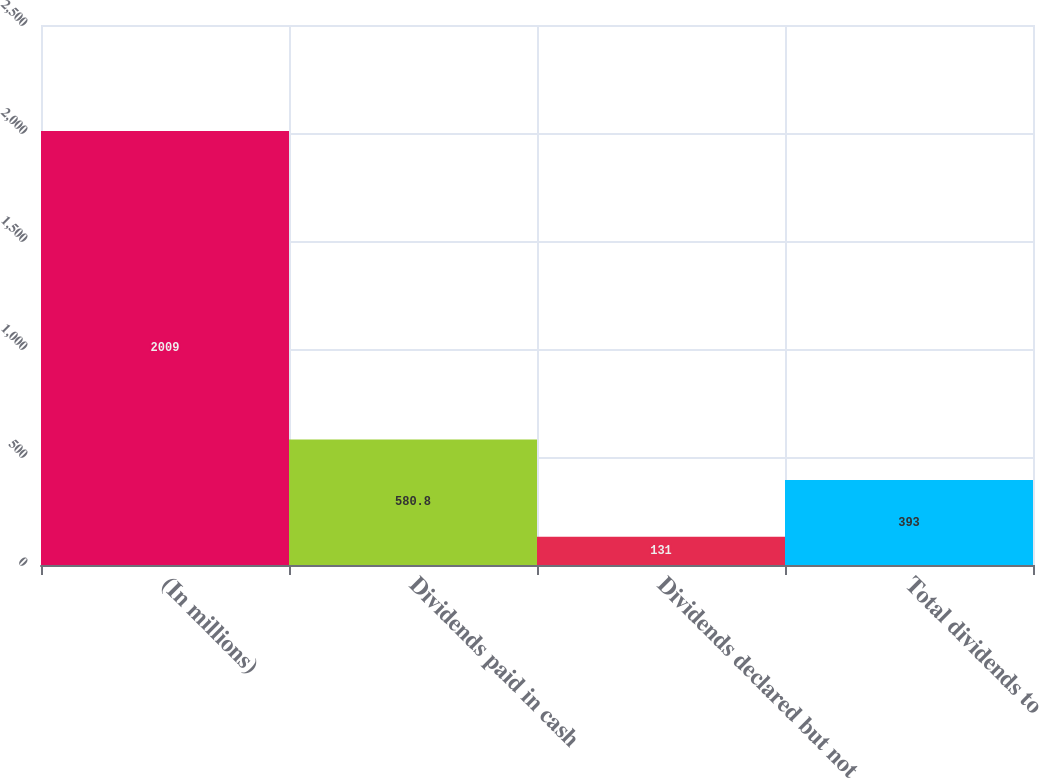Convert chart to OTSL. <chart><loc_0><loc_0><loc_500><loc_500><bar_chart><fcel>(In millions)<fcel>Dividends paid in cash<fcel>Dividends declared but not<fcel>Total dividends to<nl><fcel>2009<fcel>580.8<fcel>131<fcel>393<nl></chart> 